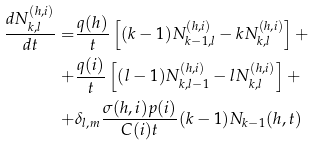Convert formula to latex. <formula><loc_0><loc_0><loc_500><loc_500>\frac { d N ^ { ( h , i ) } _ { k , l } } { d t } = & \frac { q ( h ) } { t } \left [ ( k - 1 ) N ^ { ( h , i ) } _ { k - 1 , l } - k N ^ { ( h , i ) } _ { k , l } \right ] + \\ + & \frac { q ( i ) } { t } \left [ ( l - 1 ) N ^ { ( h , i ) } _ { k , l - 1 } - l N ^ { ( h , i ) } _ { k , l } \right ] + \\ + & \delta _ { l , m } \frac { \sigma ( h , i ) p ( i ) } { C ( i ) t } ( k - 1 ) N _ { k - 1 } ( h , t )</formula> 